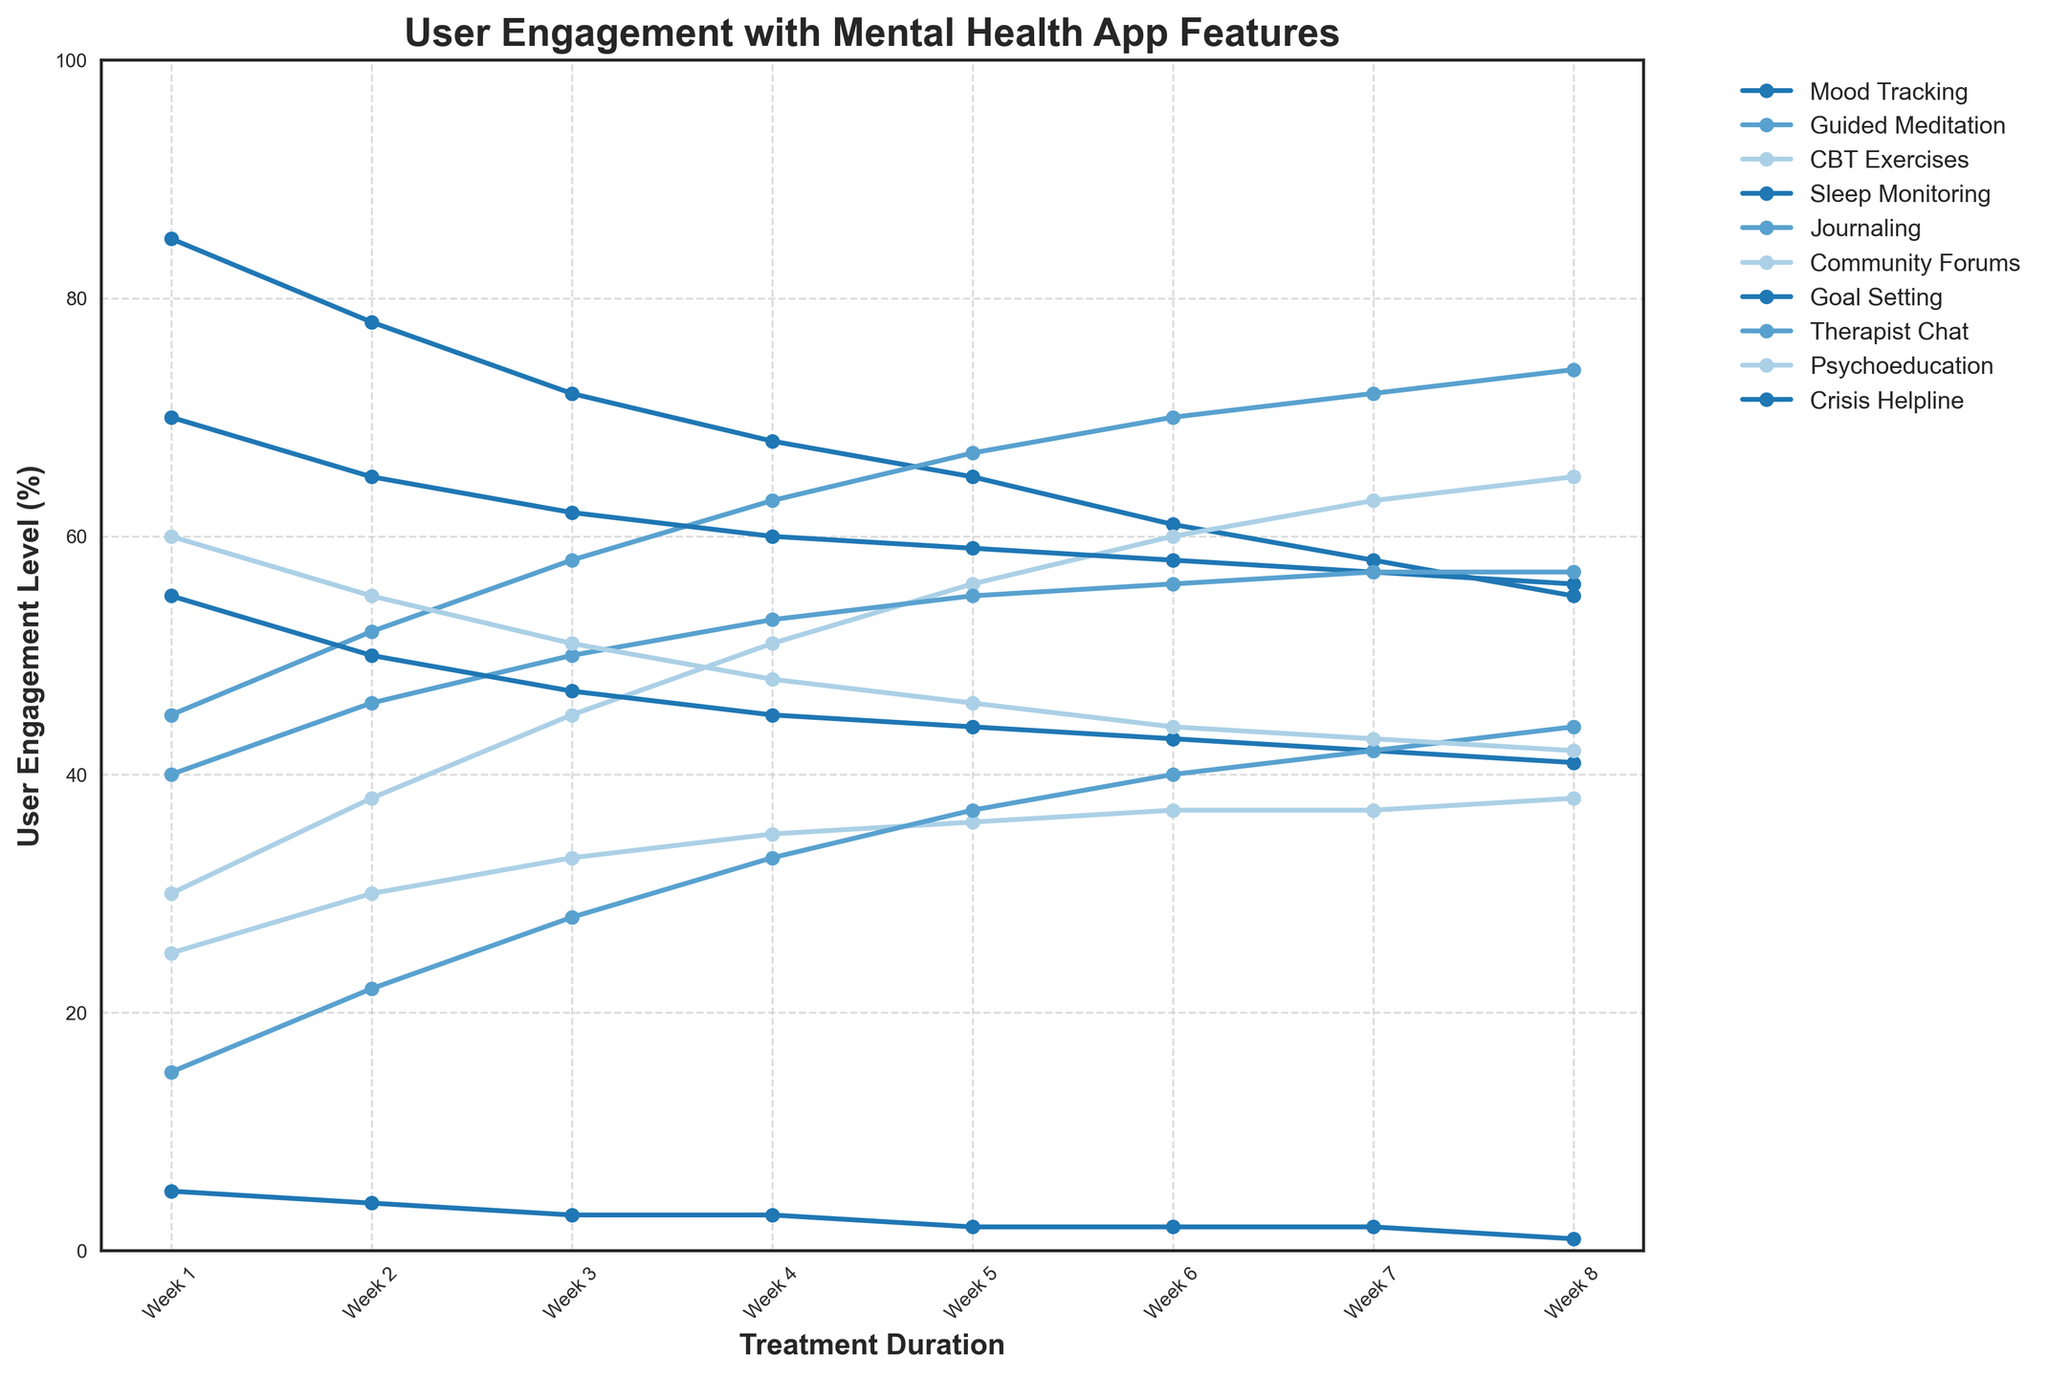Which feature had the highest user engagement in Week 1? By observing the data for Week 1, compare the engagement levels across all features. Mood Tracking has the highest value at 85.
Answer: Mood Tracking How did the user engagement for Guided Meditation change from Week 1 to Week 8? By tracing the Guided Meditation line from Week 1 to Week 8, note the values: 45 (Week 1), 74 (Week 8). Calculate the difference: 74 - 45 = 29.
Answer: Increased by 29 What is the average user engagement for CBT Exercises over the 8 weeks? Add the weekly values for CBT Exercises: 30 + 38 + 45 + 51 + 56 + 60 + 63 + 65 = 408. Divide by 8: 408 / 8 = 51.
Answer: 51 Which feature displayed a steady increase in user engagement without any decrease? Examine the trends of each feature. Guided Meditation (45 to 74), CBT Exercises (30 to 65), Journaling (40 to 57), Community Forums (25 to 38), and Therapist Chat (15 to 44) show continuous increase.
Answer: Guided Meditation, CBT Exercises, Journaling, Community Forums, Therapist Chat Among the Crisis Helpline and Therapist Chat features, which had the lowest engagement level in Week 4? Compare Week 4 values for Crisis Helpline (3) and Therapist Chat (33). Crisis Helpline has the lower value.
Answer: Crisis Helpline Which feature experienced the largest decline in engagement from Week 1 to Week 2? Calculate the drop for each feature: Mood Tracking (85-78=7), Sleep Monitoring (70-65=5), Goal Setting (55-50=5), Psychoeducation (60-55=5), Crisis Helpline (5-4=1). Mood Tracking has the largest decline of 7.
Answer: Mood Tracking Did any feature end with the same engagement level as it started with? Compare initial and final values of each feature. Journaling starts and ends at 57.
Answer: Journaling Which two features have nearly converging user engagement levels by Week 8? Analyze Week 8 values to find close proximity pairs: Journaling (57) and Sleep Monitoring (56), CBT Exercises (65) and Guided Meditation (74) are relatively close.
Answer: Journaling and Sleep Monitoring What is the difference in engagement levels between Mood Tracking and Psychoeducation by Week 5? Compare Week 5 values: Mood Tracking (65) and Psychoeducation (46). Calculate the difference: 65 - 46 = 19.
Answer: 19 